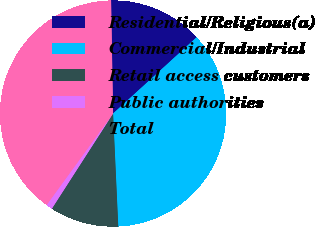Convert chart. <chart><loc_0><loc_0><loc_500><loc_500><pie_chart><fcel>Residential/Religious(a)<fcel>Commercial/Industrial<fcel>Retail access customers<fcel>Public authorities<fcel>Total<nl><fcel>13.5%<fcel>36.05%<fcel>9.83%<fcel>0.9%<fcel>39.72%<nl></chart> 